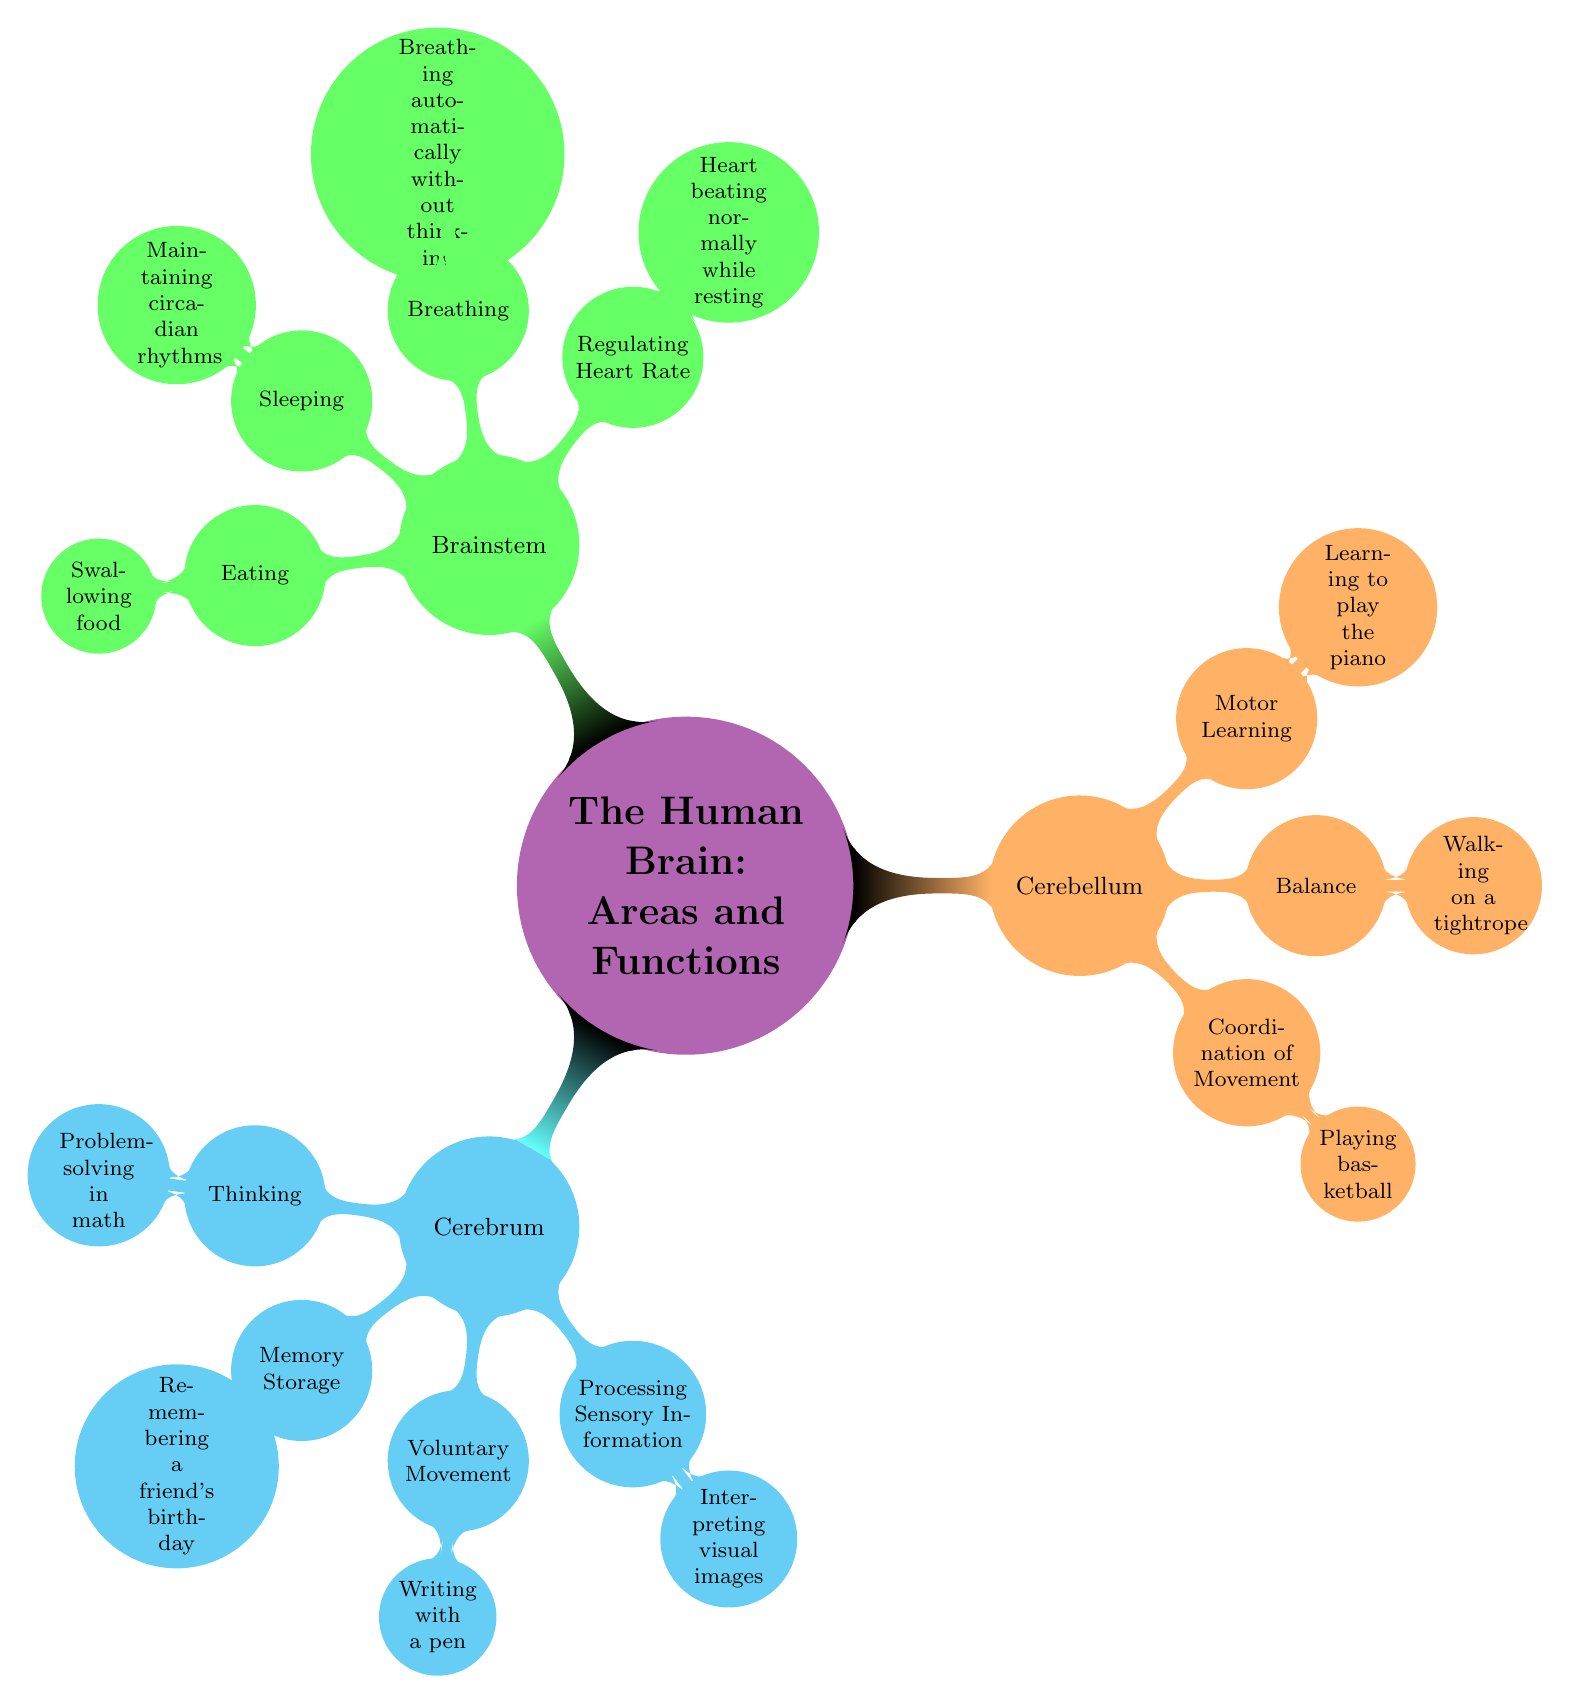What's the central node of the mind map? The central node is outlined at the top of the diagram and it states "The Human Brain: Areas and Functions", which serves as the main topic of the mind map.
Answer: The Human Brain: Areas and Functions How many main areas of the brain are detailed in the diagram? There are three main areas displayed in the diagram: Cerebrum, Cerebellum, and Brainstem. These areas branch out from the central node.
Answer: Three What function is associated with the cerebellum? The cerebellum's function section includes "Coordination of Movement", which is a primary function highlighted for this area in the diagram.
Answer: Coordination of Movement Which area of the brain regulates heart rate? The brainstem is responsible for regulating heart rate, as noted in the functions list associated with this area in the diagram.
Answer: Brainstem Give an example of a function associated with "Thinking". Under the cerebrum node, the specific function "Thinking" includes the example "Problem-solving in math". This is provided directly in the sub-nodes of the cerebrum.
Answer: Problem-solving in math What function is uniquely related to the brainstem? The function "Breathing" is listed under the brainstem, highlighting its unique role in automatic bodily functions. This distinguishes it from other areas which focus more on voluntary actions.
Answer: Breathing Which example is provided for "Motor Learning"? The diagram specifies the "Learning to play the piano" as an example of the "Motor Learning" function associated with the cerebellum area.
Answer: Learning to play the piano How is the function "Sleep" related to the brainstem? The diagram notes that the brainstem is responsible for functions like "Sleeping", illustrating its role in maintaining circadian rhythms as part of its broader function set.
Answer: Sleeping What is the primary function of the cerebrum related to memory? The cerebrum addresses "Memory Storage", which includes an example of "Remembering a friend's birthday", clarifying its role in memory processing.
Answer: Memory Storage 